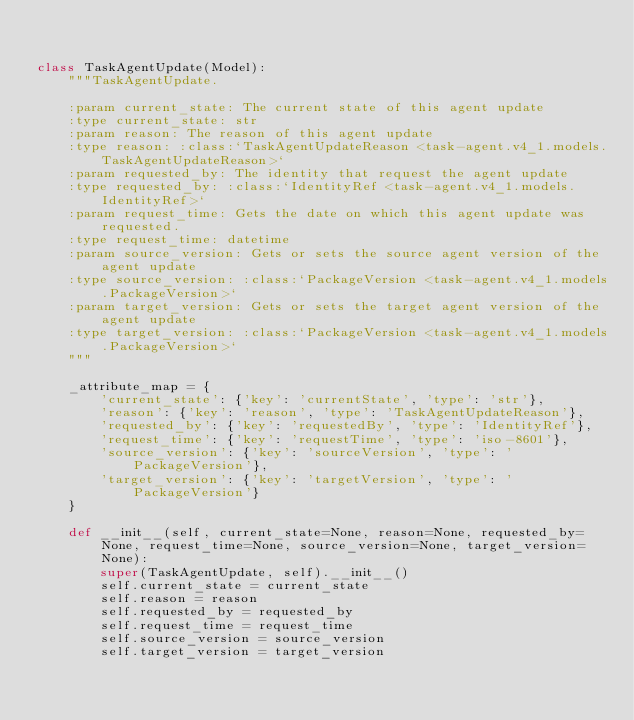Convert code to text. <code><loc_0><loc_0><loc_500><loc_500><_Python_>

class TaskAgentUpdate(Model):
    """TaskAgentUpdate.

    :param current_state: The current state of this agent update
    :type current_state: str
    :param reason: The reason of this agent update
    :type reason: :class:`TaskAgentUpdateReason <task-agent.v4_1.models.TaskAgentUpdateReason>`
    :param requested_by: The identity that request the agent update
    :type requested_by: :class:`IdentityRef <task-agent.v4_1.models.IdentityRef>`
    :param request_time: Gets the date on which this agent update was requested.
    :type request_time: datetime
    :param source_version: Gets or sets the source agent version of the agent update
    :type source_version: :class:`PackageVersion <task-agent.v4_1.models.PackageVersion>`
    :param target_version: Gets or sets the target agent version of the agent update
    :type target_version: :class:`PackageVersion <task-agent.v4_1.models.PackageVersion>`
    """

    _attribute_map = {
        'current_state': {'key': 'currentState', 'type': 'str'},
        'reason': {'key': 'reason', 'type': 'TaskAgentUpdateReason'},
        'requested_by': {'key': 'requestedBy', 'type': 'IdentityRef'},
        'request_time': {'key': 'requestTime', 'type': 'iso-8601'},
        'source_version': {'key': 'sourceVersion', 'type': 'PackageVersion'},
        'target_version': {'key': 'targetVersion', 'type': 'PackageVersion'}
    }

    def __init__(self, current_state=None, reason=None, requested_by=None, request_time=None, source_version=None, target_version=None):
        super(TaskAgentUpdate, self).__init__()
        self.current_state = current_state
        self.reason = reason
        self.requested_by = requested_by
        self.request_time = request_time
        self.source_version = source_version
        self.target_version = target_version
</code> 